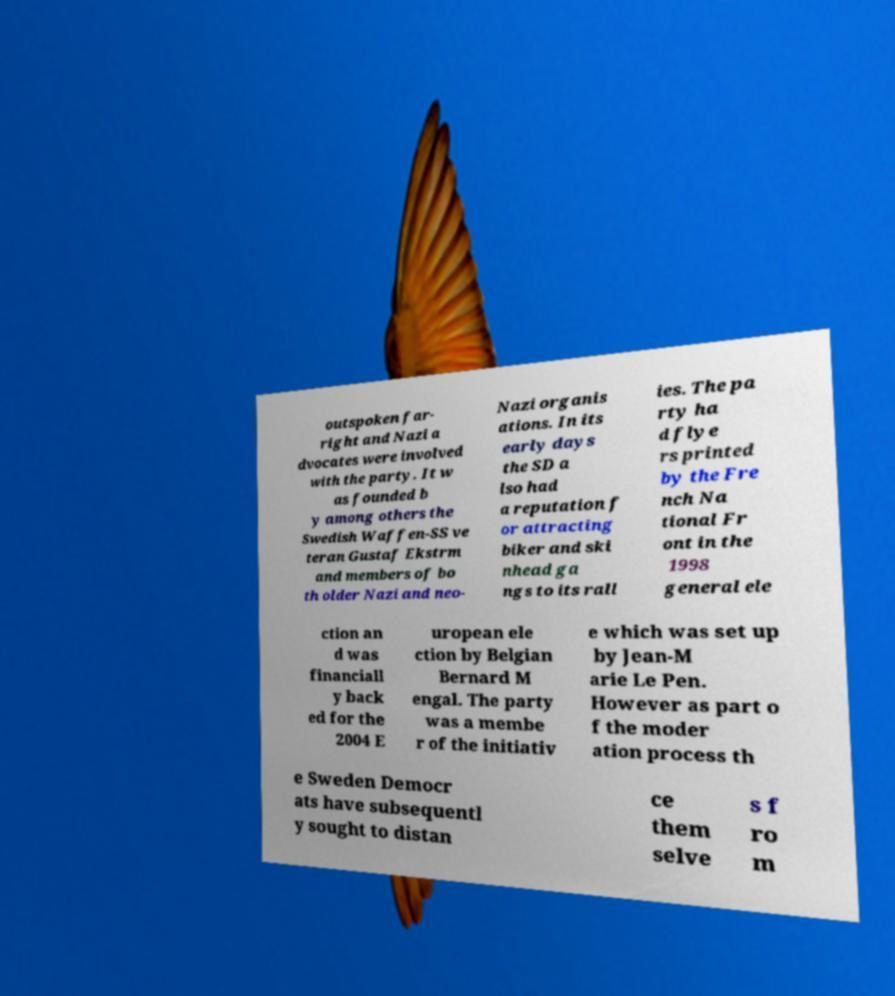Please identify and transcribe the text found in this image. outspoken far- right and Nazi a dvocates were involved with the party. It w as founded b y among others the Swedish Waffen-SS ve teran Gustaf Ekstrm and members of bo th older Nazi and neo- Nazi organis ations. In its early days the SD a lso had a reputation f or attracting biker and ski nhead ga ngs to its rall ies. The pa rty ha d flye rs printed by the Fre nch Na tional Fr ont in the 1998 general ele ction an d was financiall y back ed for the 2004 E uropean ele ction by Belgian Bernard M engal. The party was a membe r of the initiativ e which was set up by Jean-M arie Le Pen. However as part o f the moder ation process th e Sweden Democr ats have subsequentl y sought to distan ce them selve s f ro m 